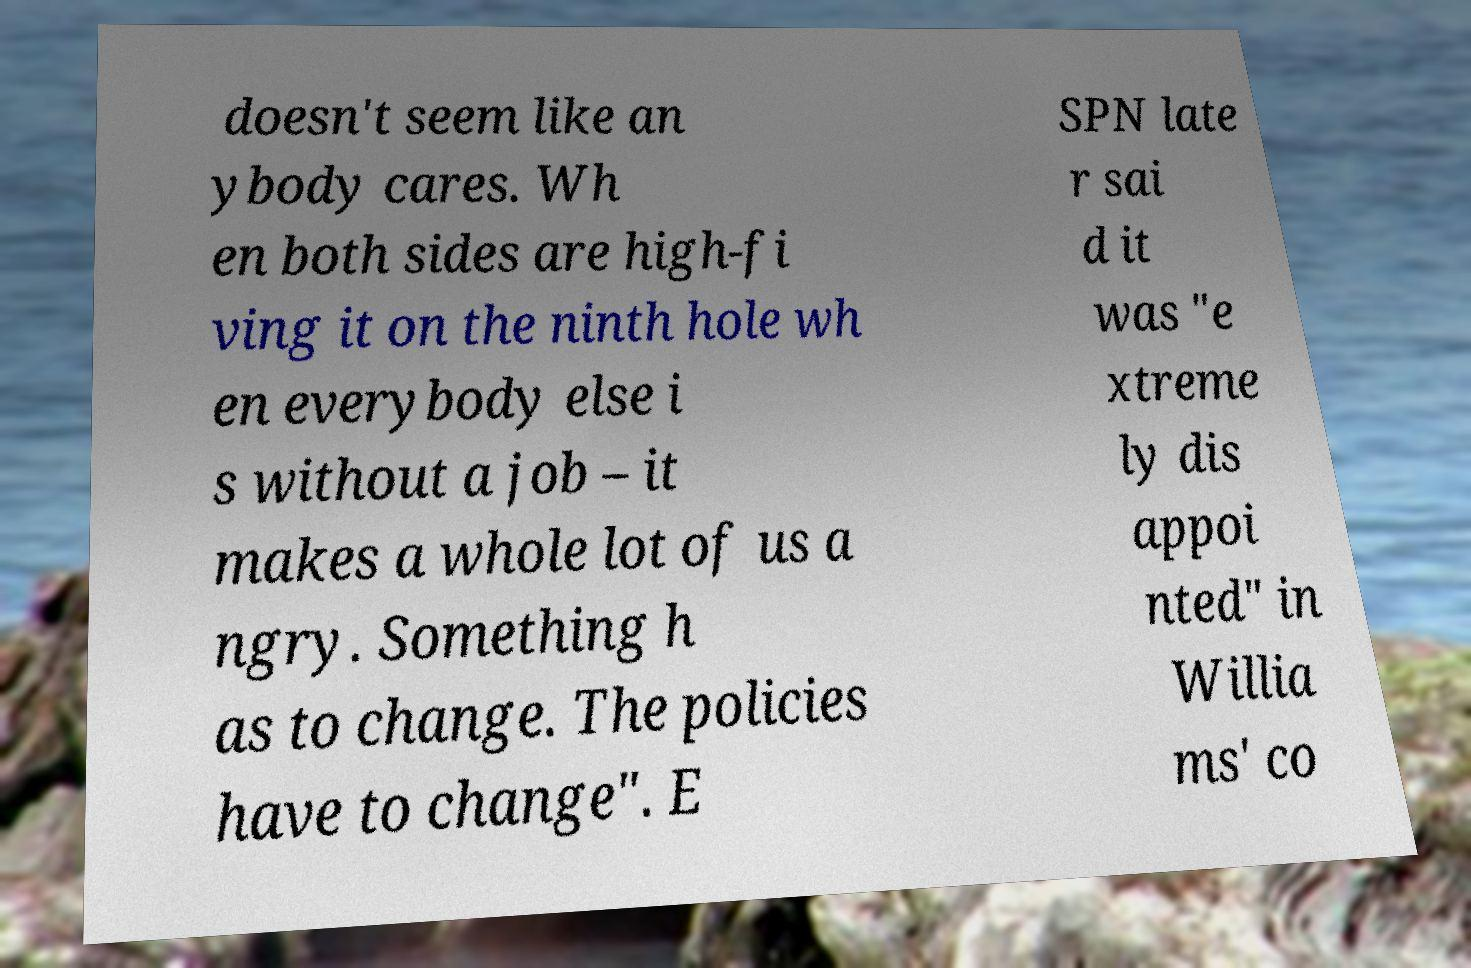What messages or text are displayed in this image? I need them in a readable, typed format. doesn't seem like an ybody cares. Wh en both sides are high-fi ving it on the ninth hole wh en everybody else i s without a job – it makes a whole lot of us a ngry. Something h as to change. The policies have to change". E SPN late r sai d it was "e xtreme ly dis appoi nted" in Willia ms' co 